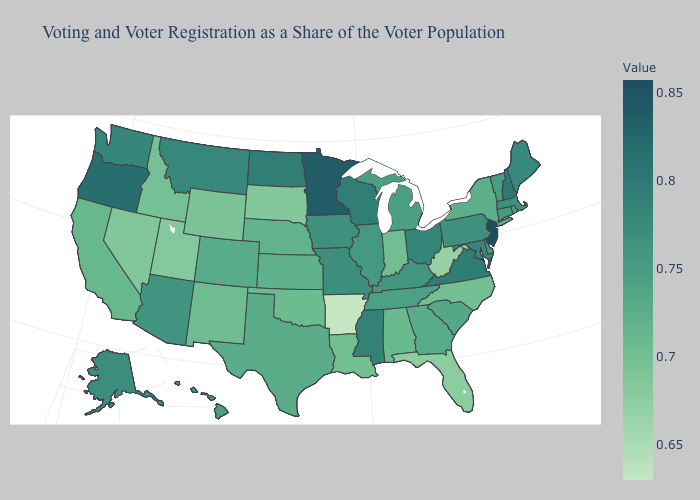Does the map have missing data?
Answer briefly. No. Which states have the lowest value in the USA?
Short answer required. Arkansas. Which states hav the highest value in the South?
Short answer required. Virginia. Among the states that border Connecticut , which have the highest value?
Give a very brief answer. Massachusetts. Among the states that border Indiana , which have the lowest value?
Keep it brief. Michigan. Among the states that border Oklahoma , does New Mexico have the lowest value?
Keep it brief. No. 